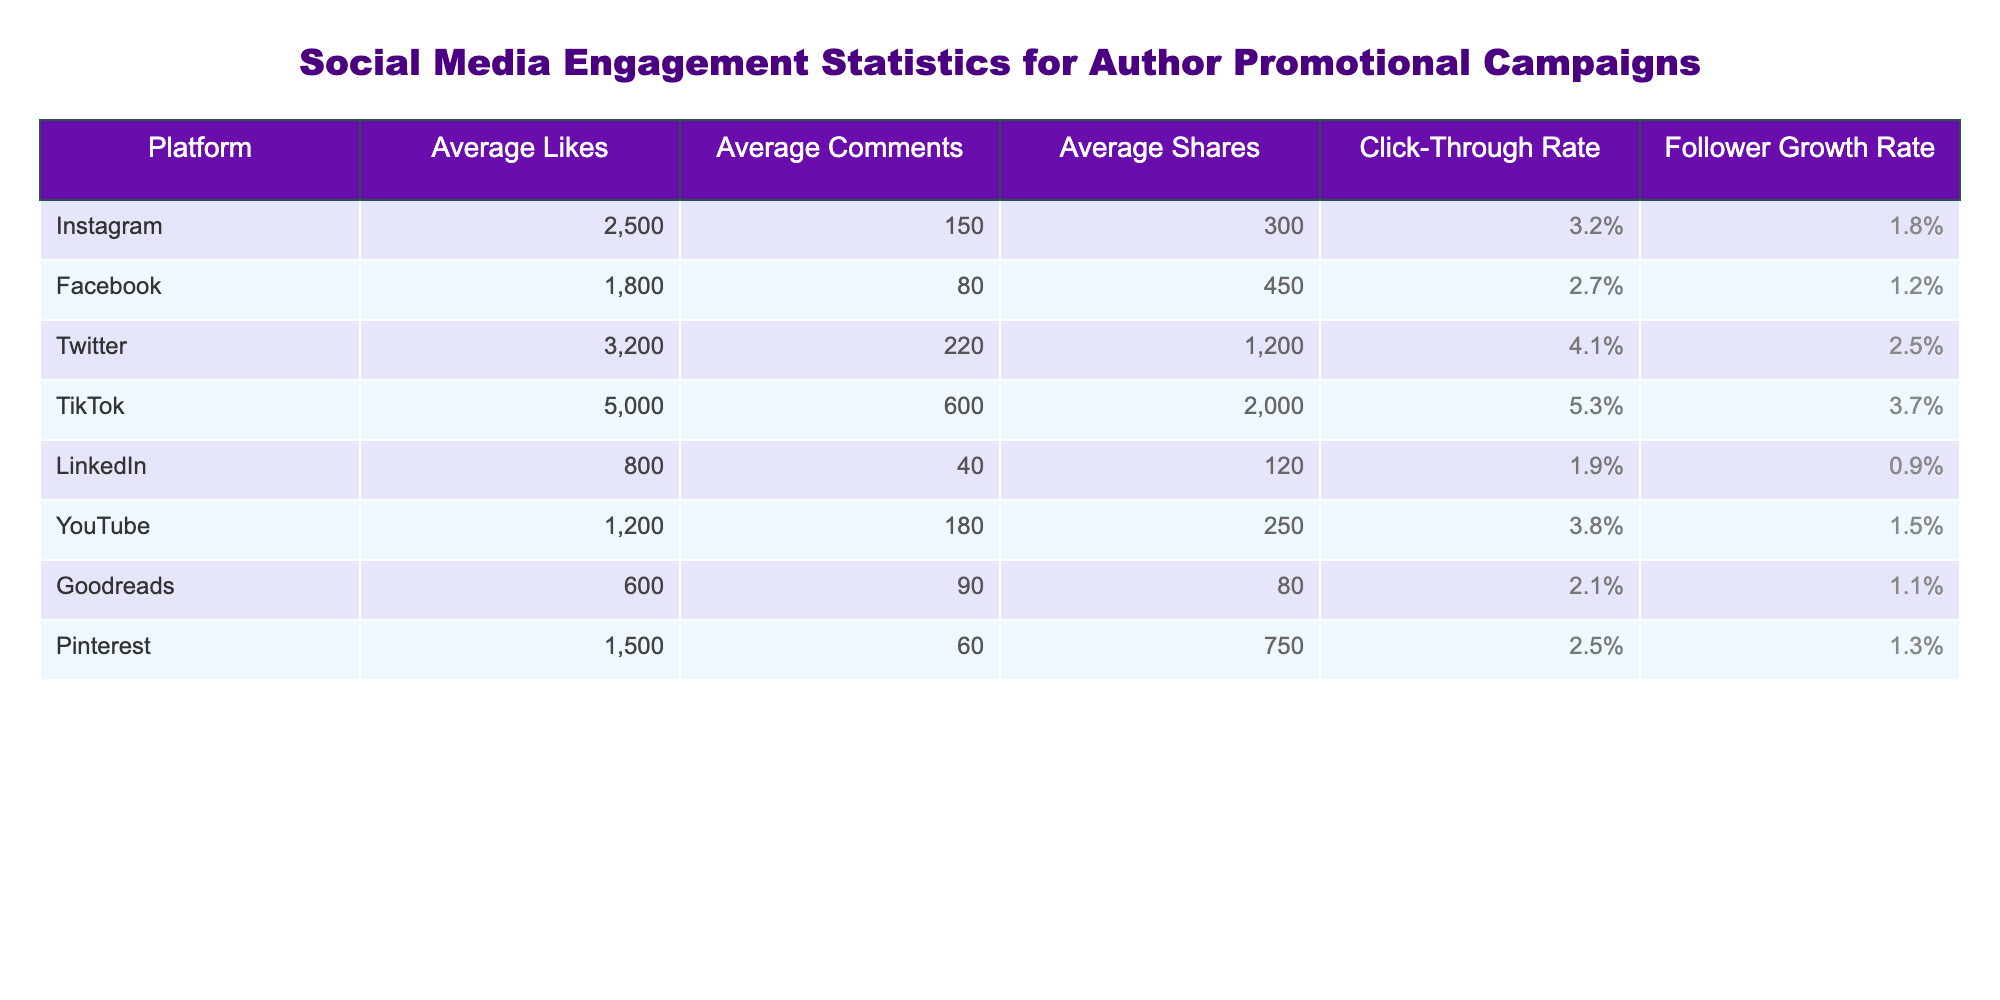What is the average number of likes on TikTok? The table indicates that TikTok has an average of 5000 likes.
Answer: 5000 Which platform has the highest average shares? According to the table, Twitter has the highest average shares with 1200.
Answer: Twitter What is the average click-through rate for Facebook? The table shows that Facebook's average click-through rate is 2.7%.
Answer: 2.7% Which platform's follower growth rate is the lowest? From the data, LinkedIn has the lowest follower growth rate at 0.9%.
Answer: LinkedIn What is the total average number of shares across all platforms? Summing all the average shares: 300 + 450 + 1200 + 2000 + 120 + 250 + 80 + 750 = 5150.
Answer: 5150 Is the average number of comments on Instagram higher than on YouTube? The table indicates Instagram has 150 average comments while YouTube has 180. Therefore, the statement is false.
Answer: No What is the average number of likes across all platforms? To find the average, sum the likes (2500 + 1800 + 3200 + 5000 + 800 + 1200 + 600 + 1500 = 15700) and then divide by the number of platforms (8): 15700/8 = 1962.5.
Answer: 1962.5 Which platform has a higher click-through rate, Twitter or Instagram? The click-through rate for Twitter is 4.1% and for Instagram is 3.2%, so Twitter has the higher rate.
Answer: Twitter If we consider platforms with a click-through rate above 3%, how many are there? The platforms with rates above 3% are TikTok (5.3%), Twitter (4.1%), and YouTube (3.8%). So, there are 3 platforms.
Answer: 3 What is the difference in average likes between TikTok and Facebook? TikTok has 5000 likes and Facebook has 1800, so the difference is 5000 - 1800 = 3200.
Answer: 3200 